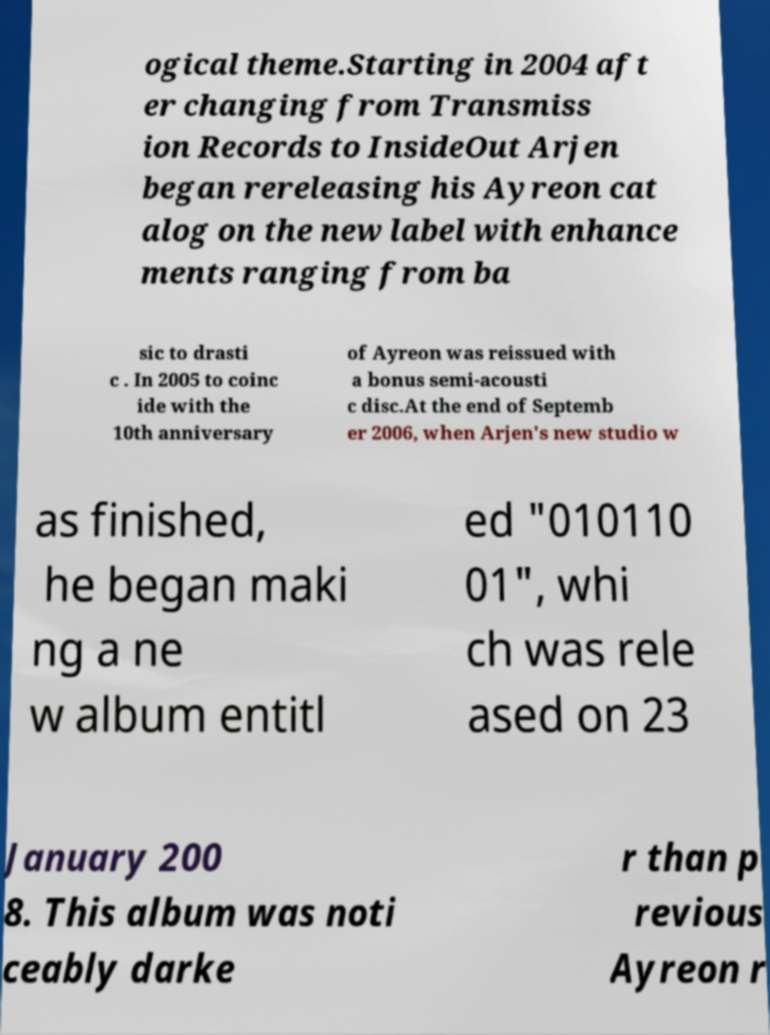I need the written content from this picture converted into text. Can you do that? ogical theme.Starting in 2004 aft er changing from Transmiss ion Records to InsideOut Arjen began rereleasing his Ayreon cat alog on the new label with enhance ments ranging from ba sic to drasti c . In 2005 to coinc ide with the 10th anniversary of Ayreon was reissued with a bonus semi-acousti c disc.At the end of Septemb er 2006, when Arjen's new studio w as finished, he began maki ng a ne w album entitl ed "010110 01", whi ch was rele ased on 23 January 200 8. This album was noti ceably darke r than p revious Ayreon r 